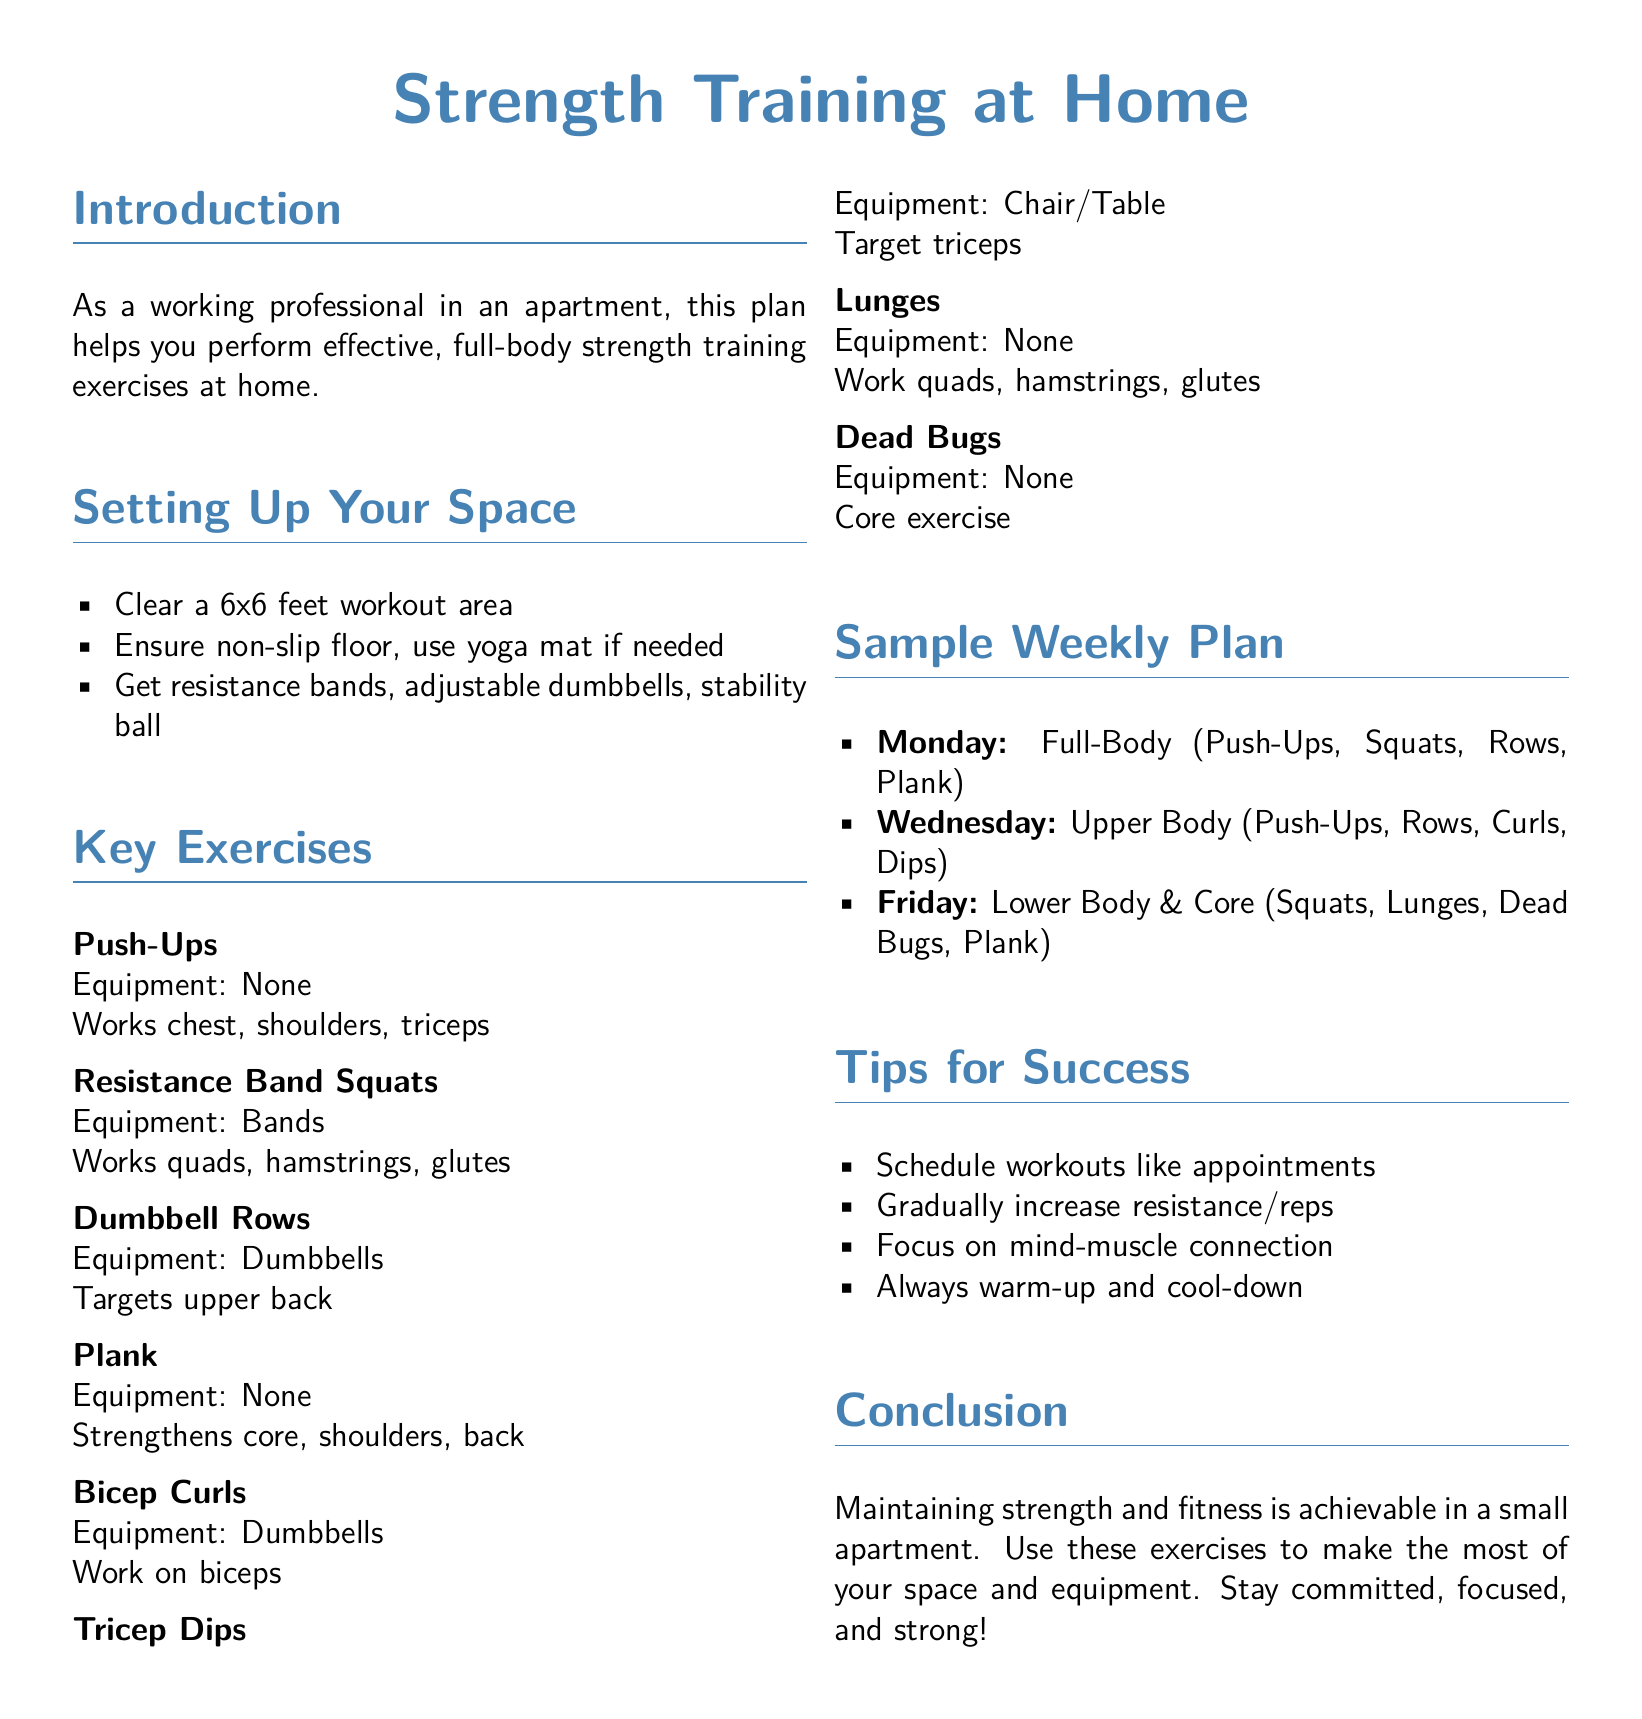What are the key exercises in the plan? The key exercises are listed in the "Key Exercises" section, which includes Push-Ups, Resistance Band Squats, Dumbbell Rows, Plank, Bicep Curls, Tricep Dips, Lunges, and Dead Bugs.
Answer: Push-Ups, Resistance Band Squats, Dumbbell Rows, Plank, Bicep Curls, Tricep Dips, Lunges, Dead Bugs How many days a week is the sample workout plan designed for? The sample weekly plan outlines workouts for three days a week, specifically Monday, Wednesday, and Friday.
Answer: Three days What equipment is recommended for the workouts? The document lists recommended equipment under "Setting Up Your Space," including resistance bands, adjustable dumbbells, and a stability ball.
Answer: Resistance bands, adjustable dumbbells, stability ball What is the focus of the Friday workout? The focus of the Friday workout is specified in the sample weekly plan as "Lower Body & Core."
Answer: Lower Body & Core What should you do before and after the workouts? The "Tips for Success" section encourages performing warm-ups and cool-downs.
Answer: Warm-up and cool-down What is the recommended workout area size? The document specifies that you should clear a workout area of 6x6 feet.
Answer: 6x6 feet Which exercise targets the biceps? The "Key Exercises" section includes Bicep Curls, which specifically work on the biceps.
Answer: Bicep Curls How is the workout plan aimed to fit into a professional's schedule? The "Tips for Success" suggest scheduling workouts like appointments to accommodate a busy professional life.
Answer: Schedule like appointments 